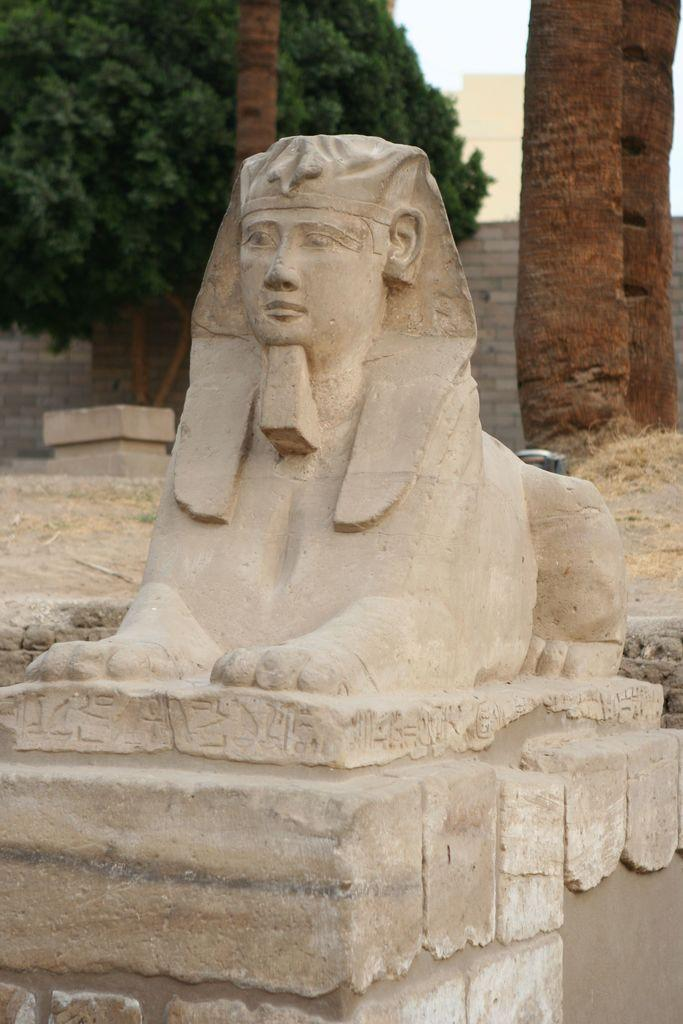What is the main subject of the image? There is a sculpture in the image. What can be seen in the background of the image? There are trees, a wall, and the sky visible in the background of the image. What type of quiver is being used by the sculpture in the image? There is no quiver present in the image, as it features a sculpture and not a person or creature holding any equipment. 